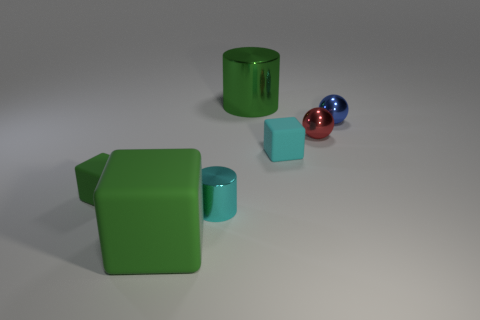Add 1 tiny green objects. How many objects exist? 8 Subtract all cubes. How many objects are left? 4 Add 7 big blocks. How many big blocks are left? 8 Add 6 small purple rubber cylinders. How many small purple rubber cylinders exist? 6 Subtract 2 green blocks. How many objects are left? 5 Subtract all red objects. Subtract all tiny green objects. How many objects are left? 5 